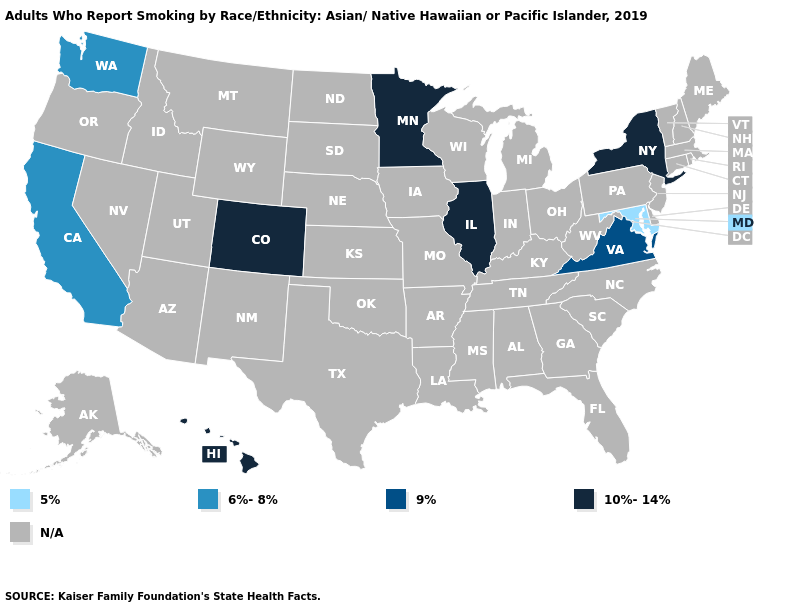Name the states that have a value in the range 5%?
Write a very short answer. Maryland. Does the first symbol in the legend represent the smallest category?
Be succinct. Yes. Name the states that have a value in the range N/A?
Concise answer only. Alabama, Alaska, Arizona, Arkansas, Connecticut, Delaware, Florida, Georgia, Idaho, Indiana, Iowa, Kansas, Kentucky, Louisiana, Maine, Massachusetts, Michigan, Mississippi, Missouri, Montana, Nebraska, Nevada, New Hampshire, New Jersey, New Mexico, North Carolina, North Dakota, Ohio, Oklahoma, Oregon, Pennsylvania, Rhode Island, South Carolina, South Dakota, Tennessee, Texas, Utah, Vermont, West Virginia, Wisconsin, Wyoming. Name the states that have a value in the range N/A?
Short answer required. Alabama, Alaska, Arizona, Arkansas, Connecticut, Delaware, Florida, Georgia, Idaho, Indiana, Iowa, Kansas, Kentucky, Louisiana, Maine, Massachusetts, Michigan, Mississippi, Missouri, Montana, Nebraska, Nevada, New Hampshire, New Jersey, New Mexico, North Carolina, North Dakota, Ohio, Oklahoma, Oregon, Pennsylvania, Rhode Island, South Carolina, South Dakota, Tennessee, Texas, Utah, Vermont, West Virginia, Wisconsin, Wyoming. What is the value of Louisiana?
Quick response, please. N/A. Name the states that have a value in the range N/A?
Give a very brief answer. Alabama, Alaska, Arizona, Arkansas, Connecticut, Delaware, Florida, Georgia, Idaho, Indiana, Iowa, Kansas, Kentucky, Louisiana, Maine, Massachusetts, Michigan, Mississippi, Missouri, Montana, Nebraska, Nevada, New Hampshire, New Jersey, New Mexico, North Carolina, North Dakota, Ohio, Oklahoma, Oregon, Pennsylvania, Rhode Island, South Carolina, South Dakota, Tennessee, Texas, Utah, Vermont, West Virginia, Wisconsin, Wyoming. Does the map have missing data?
Quick response, please. Yes. How many symbols are there in the legend?
Write a very short answer. 5. What is the value of Kansas?
Keep it brief. N/A. Is the legend a continuous bar?
Write a very short answer. No. Does the first symbol in the legend represent the smallest category?
Keep it brief. Yes. What is the value of Utah?
Answer briefly. N/A. 